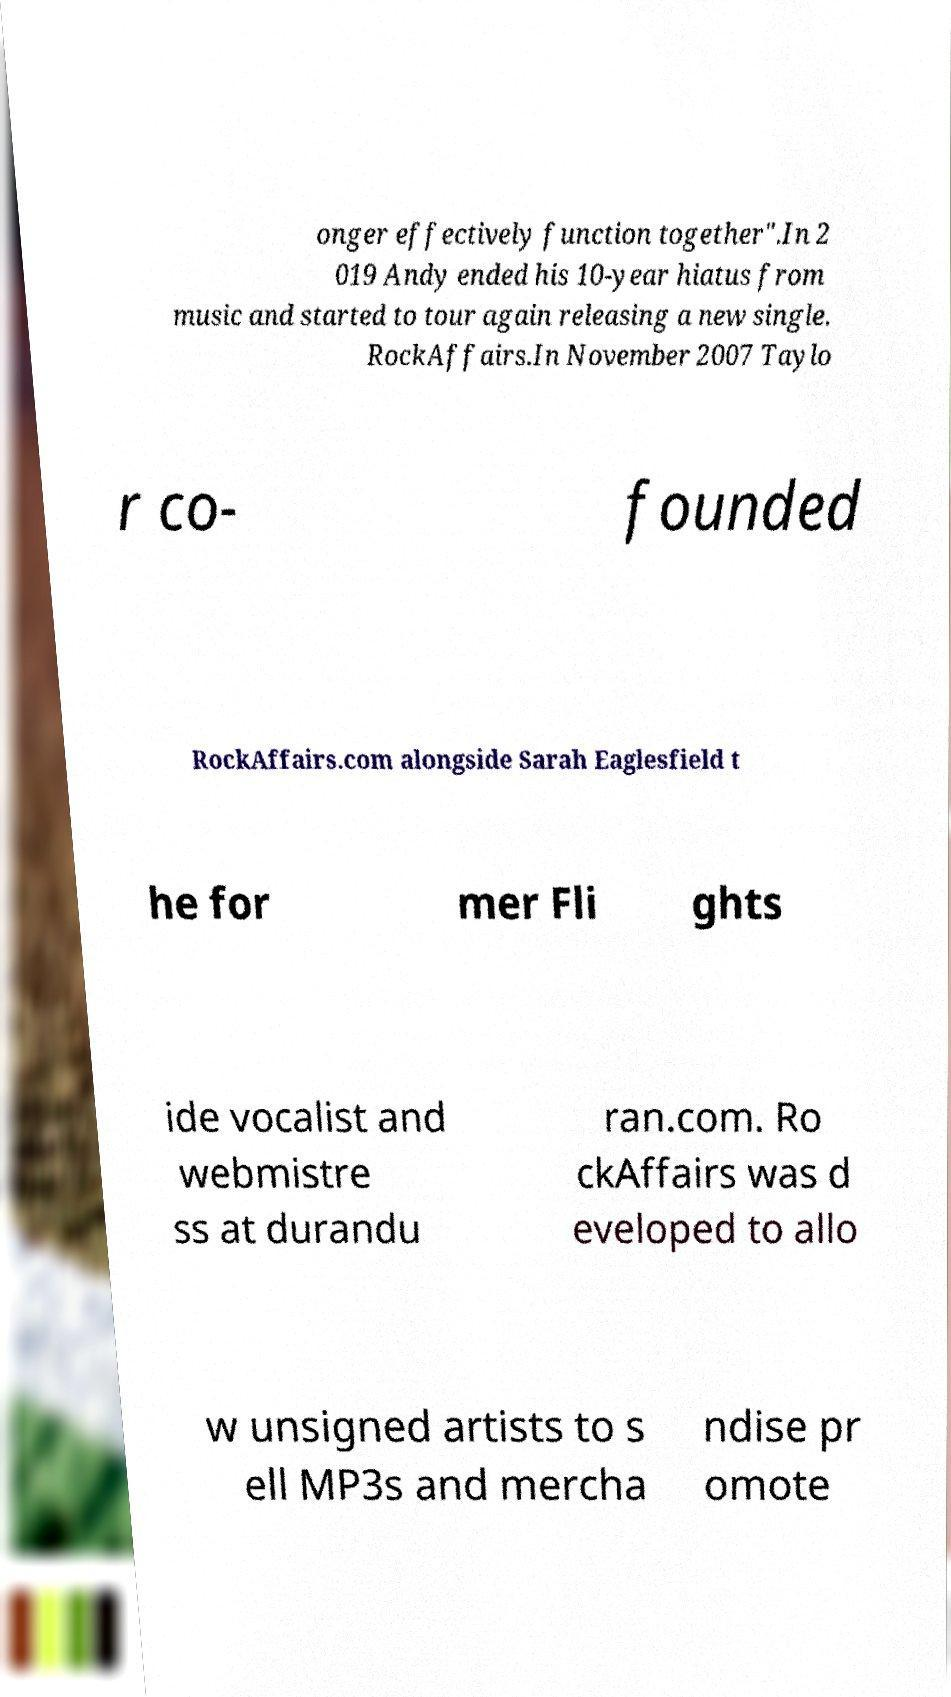For documentation purposes, I need the text within this image transcribed. Could you provide that? onger effectively function together".In 2 019 Andy ended his 10-year hiatus from music and started to tour again releasing a new single. RockAffairs.In November 2007 Taylo r co- founded RockAffairs.com alongside Sarah Eaglesfield t he for mer Fli ghts ide vocalist and webmistre ss at durandu ran.com. Ro ckAffairs was d eveloped to allo w unsigned artists to s ell MP3s and mercha ndise pr omote 